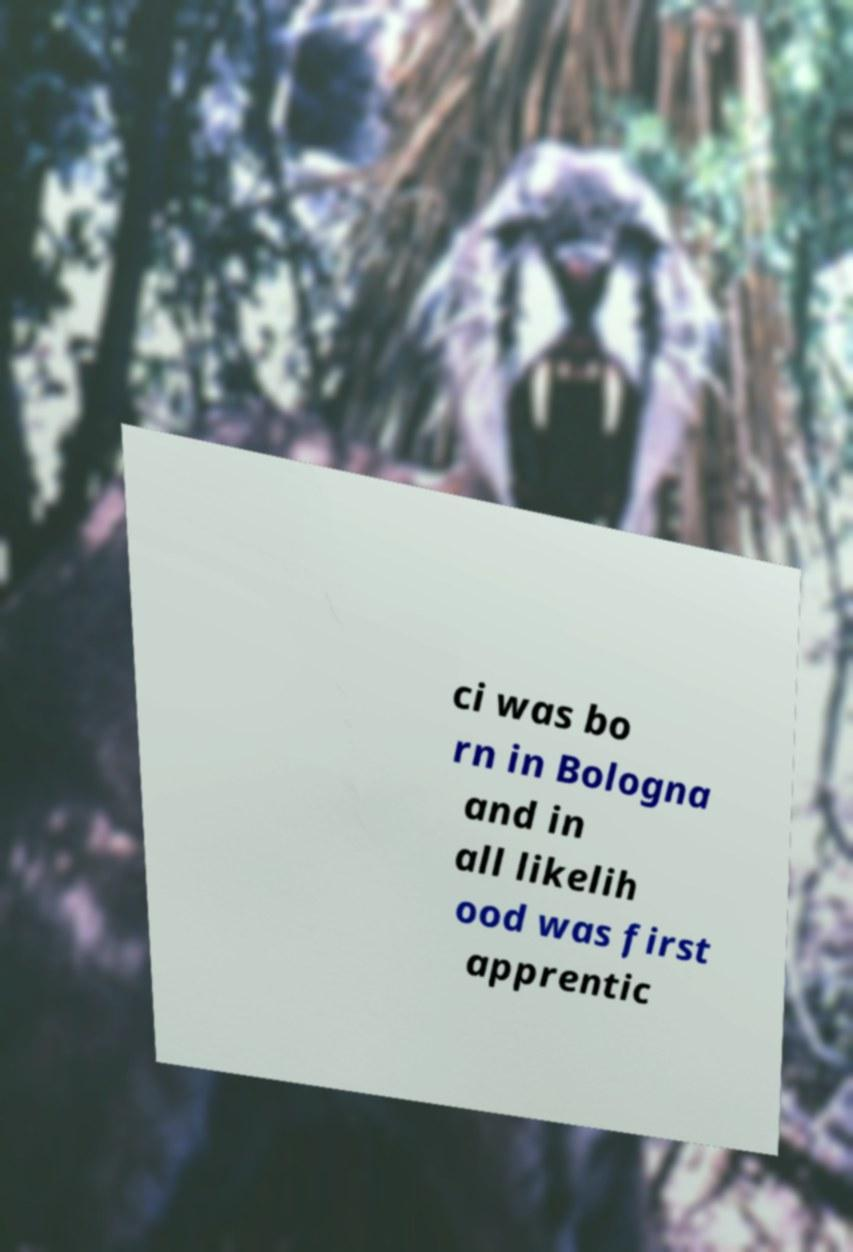For documentation purposes, I need the text within this image transcribed. Could you provide that? ci was bo rn in Bologna and in all likelih ood was first apprentic 